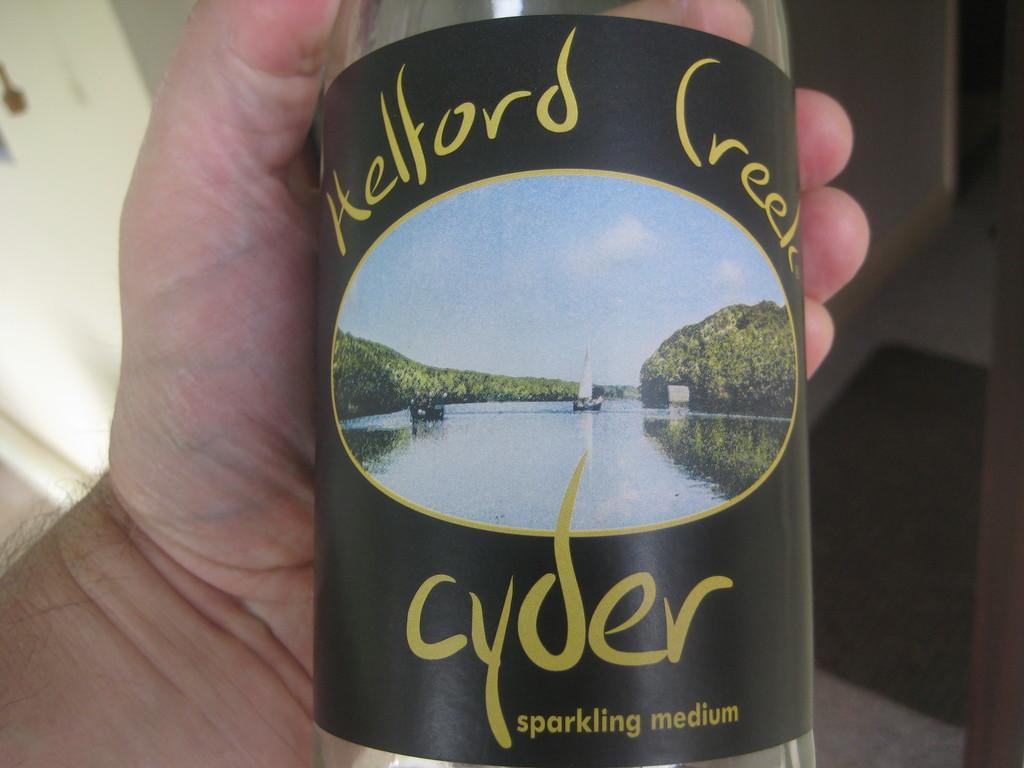Describe this image in one or two sentences. In the middle of the image a person holding a bottle, On the bottle we can see sky, water, boat, trees. 